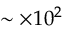<formula> <loc_0><loc_0><loc_500><loc_500>\sim \times 1 0 ^ { 2 }</formula> 